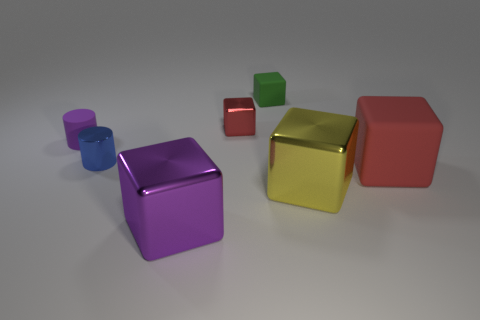The matte cube that is the same size as the purple shiny cube is what color?
Offer a terse response. Red. How many tiny red spheres are there?
Your response must be concise. 0. Are the large thing on the left side of the big yellow shiny object and the purple cylinder made of the same material?
Provide a short and direct response. No. What is the cube that is in front of the purple rubber cylinder and on the left side of the tiny green thing made of?
Make the answer very short. Metal. What size is the rubber cube that is the same color as the tiny metallic cube?
Your answer should be compact. Large. There is a large block that is to the left of the matte block on the left side of the large matte thing; what is it made of?
Make the answer very short. Metal. There is a matte thing left of the red block to the left of the cube on the right side of the large yellow block; how big is it?
Your answer should be compact. Small. How many other red blocks have the same material as the large red cube?
Ensure brevity in your answer.  0. What color is the tiny shiny thing that is behind the tiny metallic object that is left of the small red cube?
Provide a short and direct response. Red. What number of objects are either tiny shiny blocks or tiny cubes that are in front of the small green thing?
Keep it short and to the point. 1. 